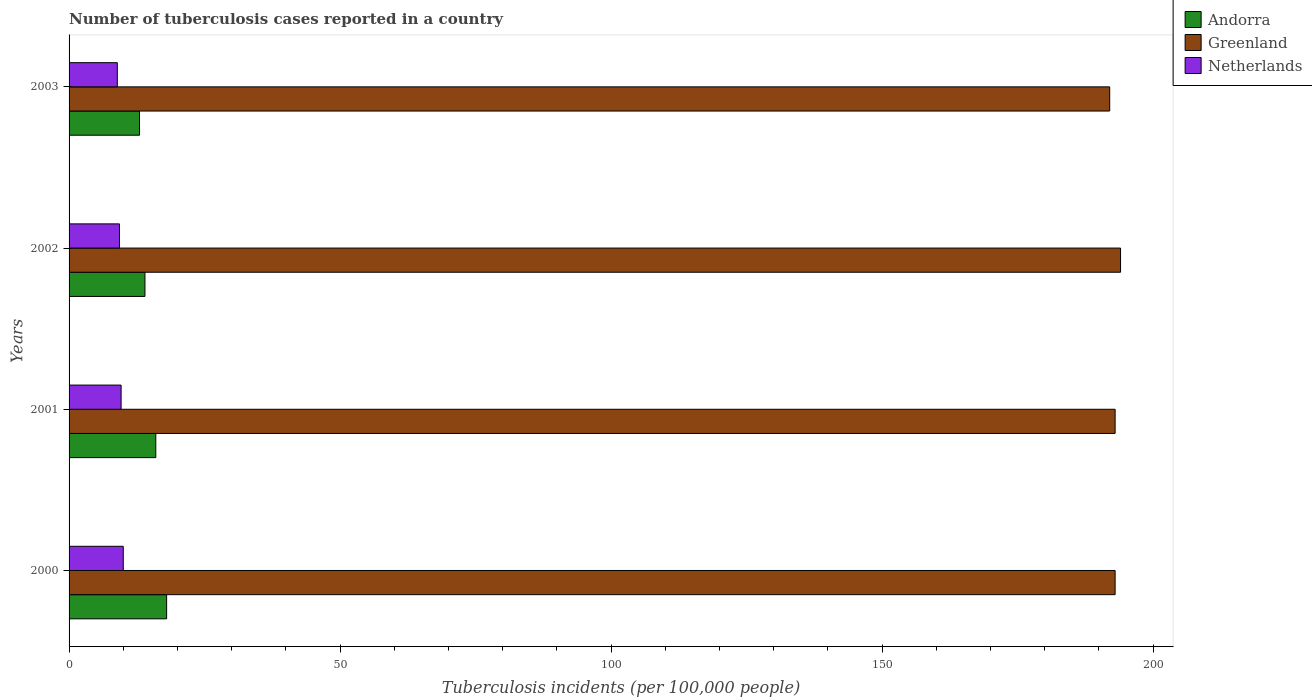How many different coloured bars are there?
Offer a terse response. 3. How many bars are there on the 1st tick from the top?
Your answer should be compact. 3. How many bars are there on the 3rd tick from the bottom?
Provide a succinct answer. 3. What is the label of the 4th group of bars from the top?
Your answer should be compact. 2000. In how many cases, is the number of bars for a given year not equal to the number of legend labels?
Your answer should be very brief. 0. What is the number of tuberculosis cases reported in in Greenland in 2002?
Your answer should be compact. 194. Across all years, what is the minimum number of tuberculosis cases reported in in Greenland?
Your answer should be compact. 192. What is the total number of tuberculosis cases reported in in Greenland in the graph?
Provide a short and direct response. 772. What is the difference between the number of tuberculosis cases reported in in Andorra in 2000 and that in 2003?
Offer a very short reply. 5. What is the difference between the number of tuberculosis cases reported in in Greenland in 2003 and the number of tuberculosis cases reported in in Netherlands in 2002?
Provide a succinct answer. 182.7. What is the average number of tuberculosis cases reported in in Greenland per year?
Make the answer very short. 193. In the year 2003, what is the difference between the number of tuberculosis cases reported in in Andorra and number of tuberculosis cases reported in in Greenland?
Make the answer very short. -179. What is the ratio of the number of tuberculosis cases reported in in Netherlands in 2001 to that in 2002?
Your response must be concise. 1.03. What is the difference between the highest and the second highest number of tuberculosis cases reported in in Netherlands?
Your response must be concise. 0.4. What is the difference between the highest and the lowest number of tuberculosis cases reported in in Netherlands?
Provide a succinct answer. 1.1. What does the 1st bar from the top in 2002 represents?
Provide a succinct answer. Netherlands. What does the 3rd bar from the bottom in 2000 represents?
Your response must be concise. Netherlands. Are all the bars in the graph horizontal?
Your answer should be compact. Yes. How many years are there in the graph?
Provide a short and direct response. 4. Are the values on the major ticks of X-axis written in scientific E-notation?
Keep it short and to the point. No. What is the title of the graph?
Your answer should be compact. Number of tuberculosis cases reported in a country. What is the label or title of the X-axis?
Ensure brevity in your answer.  Tuberculosis incidents (per 100,0 people). What is the Tuberculosis incidents (per 100,000 people) of Greenland in 2000?
Offer a very short reply. 193. What is the Tuberculosis incidents (per 100,000 people) of Greenland in 2001?
Your answer should be compact. 193. What is the Tuberculosis incidents (per 100,000 people) of Netherlands in 2001?
Your answer should be compact. 9.6. What is the Tuberculosis incidents (per 100,000 people) of Andorra in 2002?
Offer a very short reply. 14. What is the Tuberculosis incidents (per 100,000 people) in Greenland in 2002?
Provide a short and direct response. 194. What is the Tuberculosis incidents (per 100,000 people) of Greenland in 2003?
Offer a terse response. 192. What is the Tuberculosis incidents (per 100,000 people) in Netherlands in 2003?
Make the answer very short. 8.9. Across all years, what is the maximum Tuberculosis incidents (per 100,000 people) in Greenland?
Offer a terse response. 194. Across all years, what is the maximum Tuberculosis incidents (per 100,000 people) of Netherlands?
Your answer should be very brief. 10. Across all years, what is the minimum Tuberculosis incidents (per 100,000 people) in Greenland?
Offer a very short reply. 192. What is the total Tuberculosis incidents (per 100,000 people) of Greenland in the graph?
Your response must be concise. 772. What is the total Tuberculosis incidents (per 100,000 people) of Netherlands in the graph?
Your answer should be very brief. 37.8. What is the difference between the Tuberculosis incidents (per 100,000 people) in Andorra in 2000 and that in 2001?
Offer a terse response. 2. What is the difference between the Tuberculosis incidents (per 100,000 people) of Greenland in 2000 and that in 2001?
Ensure brevity in your answer.  0. What is the difference between the Tuberculosis incidents (per 100,000 people) in Netherlands in 2000 and that in 2001?
Your response must be concise. 0.4. What is the difference between the Tuberculosis incidents (per 100,000 people) in Greenland in 2000 and that in 2002?
Your answer should be very brief. -1. What is the difference between the Tuberculosis incidents (per 100,000 people) in Netherlands in 2000 and that in 2002?
Provide a short and direct response. 0.7. What is the difference between the Tuberculosis incidents (per 100,000 people) in Andorra in 2000 and that in 2003?
Give a very brief answer. 5. What is the difference between the Tuberculosis incidents (per 100,000 people) of Netherlands in 2000 and that in 2003?
Provide a succinct answer. 1.1. What is the difference between the Tuberculosis incidents (per 100,000 people) of Andorra in 2001 and that in 2002?
Your answer should be very brief. 2. What is the difference between the Tuberculosis incidents (per 100,000 people) in Greenland in 2001 and that in 2002?
Ensure brevity in your answer.  -1. What is the difference between the Tuberculosis incidents (per 100,000 people) in Andorra in 2001 and that in 2003?
Make the answer very short. 3. What is the difference between the Tuberculosis incidents (per 100,000 people) of Greenland in 2001 and that in 2003?
Your response must be concise. 1. What is the difference between the Tuberculosis incidents (per 100,000 people) of Andorra in 2002 and that in 2003?
Keep it short and to the point. 1. What is the difference between the Tuberculosis incidents (per 100,000 people) of Greenland in 2002 and that in 2003?
Offer a very short reply. 2. What is the difference between the Tuberculosis incidents (per 100,000 people) in Netherlands in 2002 and that in 2003?
Offer a very short reply. 0.4. What is the difference between the Tuberculosis incidents (per 100,000 people) in Andorra in 2000 and the Tuberculosis incidents (per 100,000 people) in Greenland in 2001?
Ensure brevity in your answer.  -175. What is the difference between the Tuberculosis incidents (per 100,000 people) of Greenland in 2000 and the Tuberculosis incidents (per 100,000 people) of Netherlands in 2001?
Your response must be concise. 183.4. What is the difference between the Tuberculosis incidents (per 100,000 people) of Andorra in 2000 and the Tuberculosis incidents (per 100,000 people) of Greenland in 2002?
Give a very brief answer. -176. What is the difference between the Tuberculosis incidents (per 100,000 people) in Andorra in 2000 and the Tuberculosis incidents (per 100,000 people) in Netherlands in 2002?
Your answer should be very brief. 8.7. What is the difference between the Tuberculosis incidents (per 100,000 people) of Greenland in 2000 and the Tuberculosis incidents (per 100,000 people) of Netherlands in 2002?
Your response must be concise. 183.7. What is the difference between the Tuberculosis incidents (per 100,000 people) in Andorra in 2000 and the Tuberculosis incidents (per 100,000 people) in Greenland in 2003?
Your answer should be compact. -174. What is the difference between the Tuberculosis incidents (per 100,000 people) of Greenland in 2000 and the Tuberculosis incidents (per 100,000 people) of Netherlands in 2003?
Ensure brevity in your answer.  184.1. What is the difference between the Tuberculosis incidents (per 100,000 people) of Andorra in 2001 and the Tuberculosis incidents (per 100,000 people) of Greenland in 2002?
Provide a short and direct response. -178. What is the difference between the Tuberculosis incidents (per 100,000 people) of Greenland in 2001 and the Tuberculosis incidents (per 100,000 people) of Netherlands in 2002?
Offer a very short reply. 183.7. What is the difference between the Tuberculosis incidents (per 100,000 people) of Andorra in 2001 and the Tuberculosis incidents (per 100,000 people) of Greenland in 2003?
Offer a terse response. -176. What is the difference between the Tuberculosis incidents (per 100,000 people) in Andorra in 2001 and the Tuberculosis incidents (per 100,000 people) in Netherlands in 2003?
Ensure brevity in your answer.  7.1. What is the difference between the Tuberculosis incidents (per 100,000 people) in Greenland in 2001 and the Tuberculosis incidents (per 100,000 people) in Netherlands in 2003?
Keep it short and to the point. 184.1. What is the difference between the Tuberculosis incidents (per 100,000 people) in Andorra in 2002 and the Tuberculosis incidents (per 100,000 people) in Greenland in 2003?
Ensure brevity in your answer.  -178. What is the difference between the Tuberculosis incidents (per 100,000 people) of Andorra in 2002 and the Tuberculosis incidents (per 100,000 people) of Netherlands in 2003?
Your response must be concise. 5.1. What is the difference between the Tuberculosis incidents (per 100,000 people) of Greenland in 2002 and the Tuberculosis incidents (per 100,000 people) of Netherlands in 2003?
Your response must be concise. 185.1. What is the average Tuberculosis incidents (per 100,000 people) of Andorra per year?
Keep it short and to the point. 15.25. What is the average Tuberculosis incidents (per 100,000 people) of Greenland per year?
Your answer should be compact. 193. What is the average Tuberculosis incidents (per 100,000 people) in Netherlands per year?
Provide a short and direct response. 9.45. In the year 2000, what is the difference between the Tuberculosis incidents (per 100,000 people) of Andorra and Tuberculosis incidents (per 100,000 people) of Greenland?
Your response must be concise. -175. In the year 2000, what is the difference between the Tuberculosis incidents (per 100,000 people) of Greenland and Tuberculosis incidents (per 100,000 people) of Netherlands?
Offer a terse response. 183. In the year 2001, what is the difference between the Tuberculosis incidents (per 100,000 people) in Andorra and Tuberculosis incidents (per 100,000 people) in Greenland?
Your answer should be compact. -177. In the year 2001, what is the difference between the Tuberculosis incidents (per 100,000 people) of Greenland and Tuberculosis incidents (per 100,000 people) of Netherlands?
Your response must be concise. 183.4. In the year 2002, what is the difference between the Tuberculosis incidents (per 100,000 people) in Andorra and Tuberculosis incidents (per 100,000 people) in Greenland?
Your response must be concise. -180. In the year 2002, what is the difference between the Tuberculosis incidents (per 100,000 people) in Greenland and Tuberculosis incidents (per 100,000 people) in Netherlands?
Ensure brevity in your answer.  184.7. In the year 2003, what is the difference between the Tuberculosis incidents (per 100,000 people) in Andorra and Tuberculosis incidents (per 100,000 people) in Greenland?
Ensure brevity in your answer.  -179. In the year 2003, what is the difference between the Tuberculosis incidents (per 100,000 people) in Andorra and Tuberculosis incidents (per 100,000 people) in Netherlands?
Provide a short and direct response. 4.1. In the year 2003, what is the difference between the Tuberculosis incidents (per 100,000 people) of Greenland and Tuberculosis incidents (per 100,000 people) of Netherlands?
Your answer should be very brief. 183.1. What is the ratio of the Tuberculosis incidents (per 100,000 people) of Andorra in 2000 to that in 2001?
Give a very brief answer. 1.12. What is the ratio of the Tuberculosis incidents (per 100,000 people) in Greenland in 2000 to that in 2001?
Provide a succinct answer. 1. What is the ratio of the Tuberculosis incidents (per 100,000 people) of Netherlands in 2000 to that in 2001?
Keep it short and to the point. 1.04. What is the ratio of the Tuberculosis incidents (per 100,000 people) in Greenland in 2000 to that in 2002?
Offer a very short reply. 0.99. What is the ratio of the Tuberculosis incidents (per 100,000 people) in Netherlands in 2000 to that in 2002?
Provide a short and direct response. 1.08. What is the ratio of the Tuberculosis incidents (per 100,000 people) of Andorra in 2000 to that in 2003?
Your answer should be very brief. 1.38. What is the ratio of the Tuberculosis incidents (per 100,000 people) in Netherlands in 2000 to that in 2003?
Ensure brevity in your answer.  1.12. What is the ratio of the Tuberculosis incidents (per 100,000 people) of Netherlands in 2001 to that in 2002?
Ensure brevity in your answer.  1.03. What is the ratio of the Tuberculosis incidents (per 100,000 people) of Andorra in 2001 to that in 2003?
Give a very brief answer. 1.23. What is the ratio of the Tuberculosis incidents (per 100,000 people) in Greenland in 2001 to that in 2003?
Ensure brevity in your answer.  1.01. What is the ratio of the Tuberculosis incidents (per 100,000 people) of Netherlands in 2001 to that in 2003?
Offer a very short reply. 1.08. What is the ratio of the Tuberculosis incidents (per 100,000 people) in Greenland in 2002 to that in 2003?
Offer a terse response. 1.01. What is the ratio of the Tuberculosis incidents (per 100,000 people) of Netherlands in 2002 to that in 2003?
Offer a very short reply. 1.04. What is the difference between the highest and the second highest Tuberculosis incidents (per 100,000 people) in Andorra?
Your answer should be very brief. 2. What is the difference between the highest and the second highest Tuberculosis incidents (per 100,000 people) in Netherlands?
Ensure brevity in your answer.  0.4. What is the difference between the highest and the lowest Tuberculosis incidents (per 100,000 people) in Greenland?
Your answer should be compact. 2. 